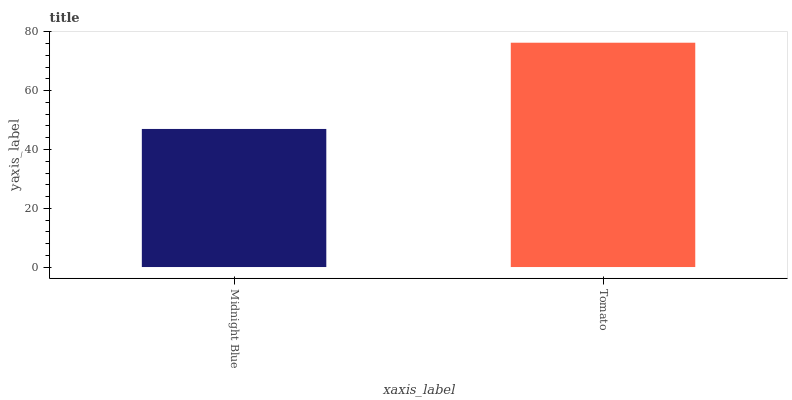Is Midnight Blue the minimum?
Answer yes or no. Yes. Is Tomato the maximum?
Answer yes or no. Yes. Is Tomato the minimum?
Answer yes or no. No. Is Tomato greater than Midnight Blue?
Answer yes or no. Yes. Is Midnight Blue less than Tomato?
Answer yes or no. Yes. Is Midnight Blue greater than Tomato?
Answer yes or no. No. Is Tomato less than Midnight Blue?
Answer yes or no. No. Is Tomato the high median?
Answer yes or no. Yes. Is Midnight Blue the low median?
Answer yes or no. Yes. Is Midnight Blue the high median?
Answer yes or no. No. Is Tomato the low median?
Answer yes or no. No. 